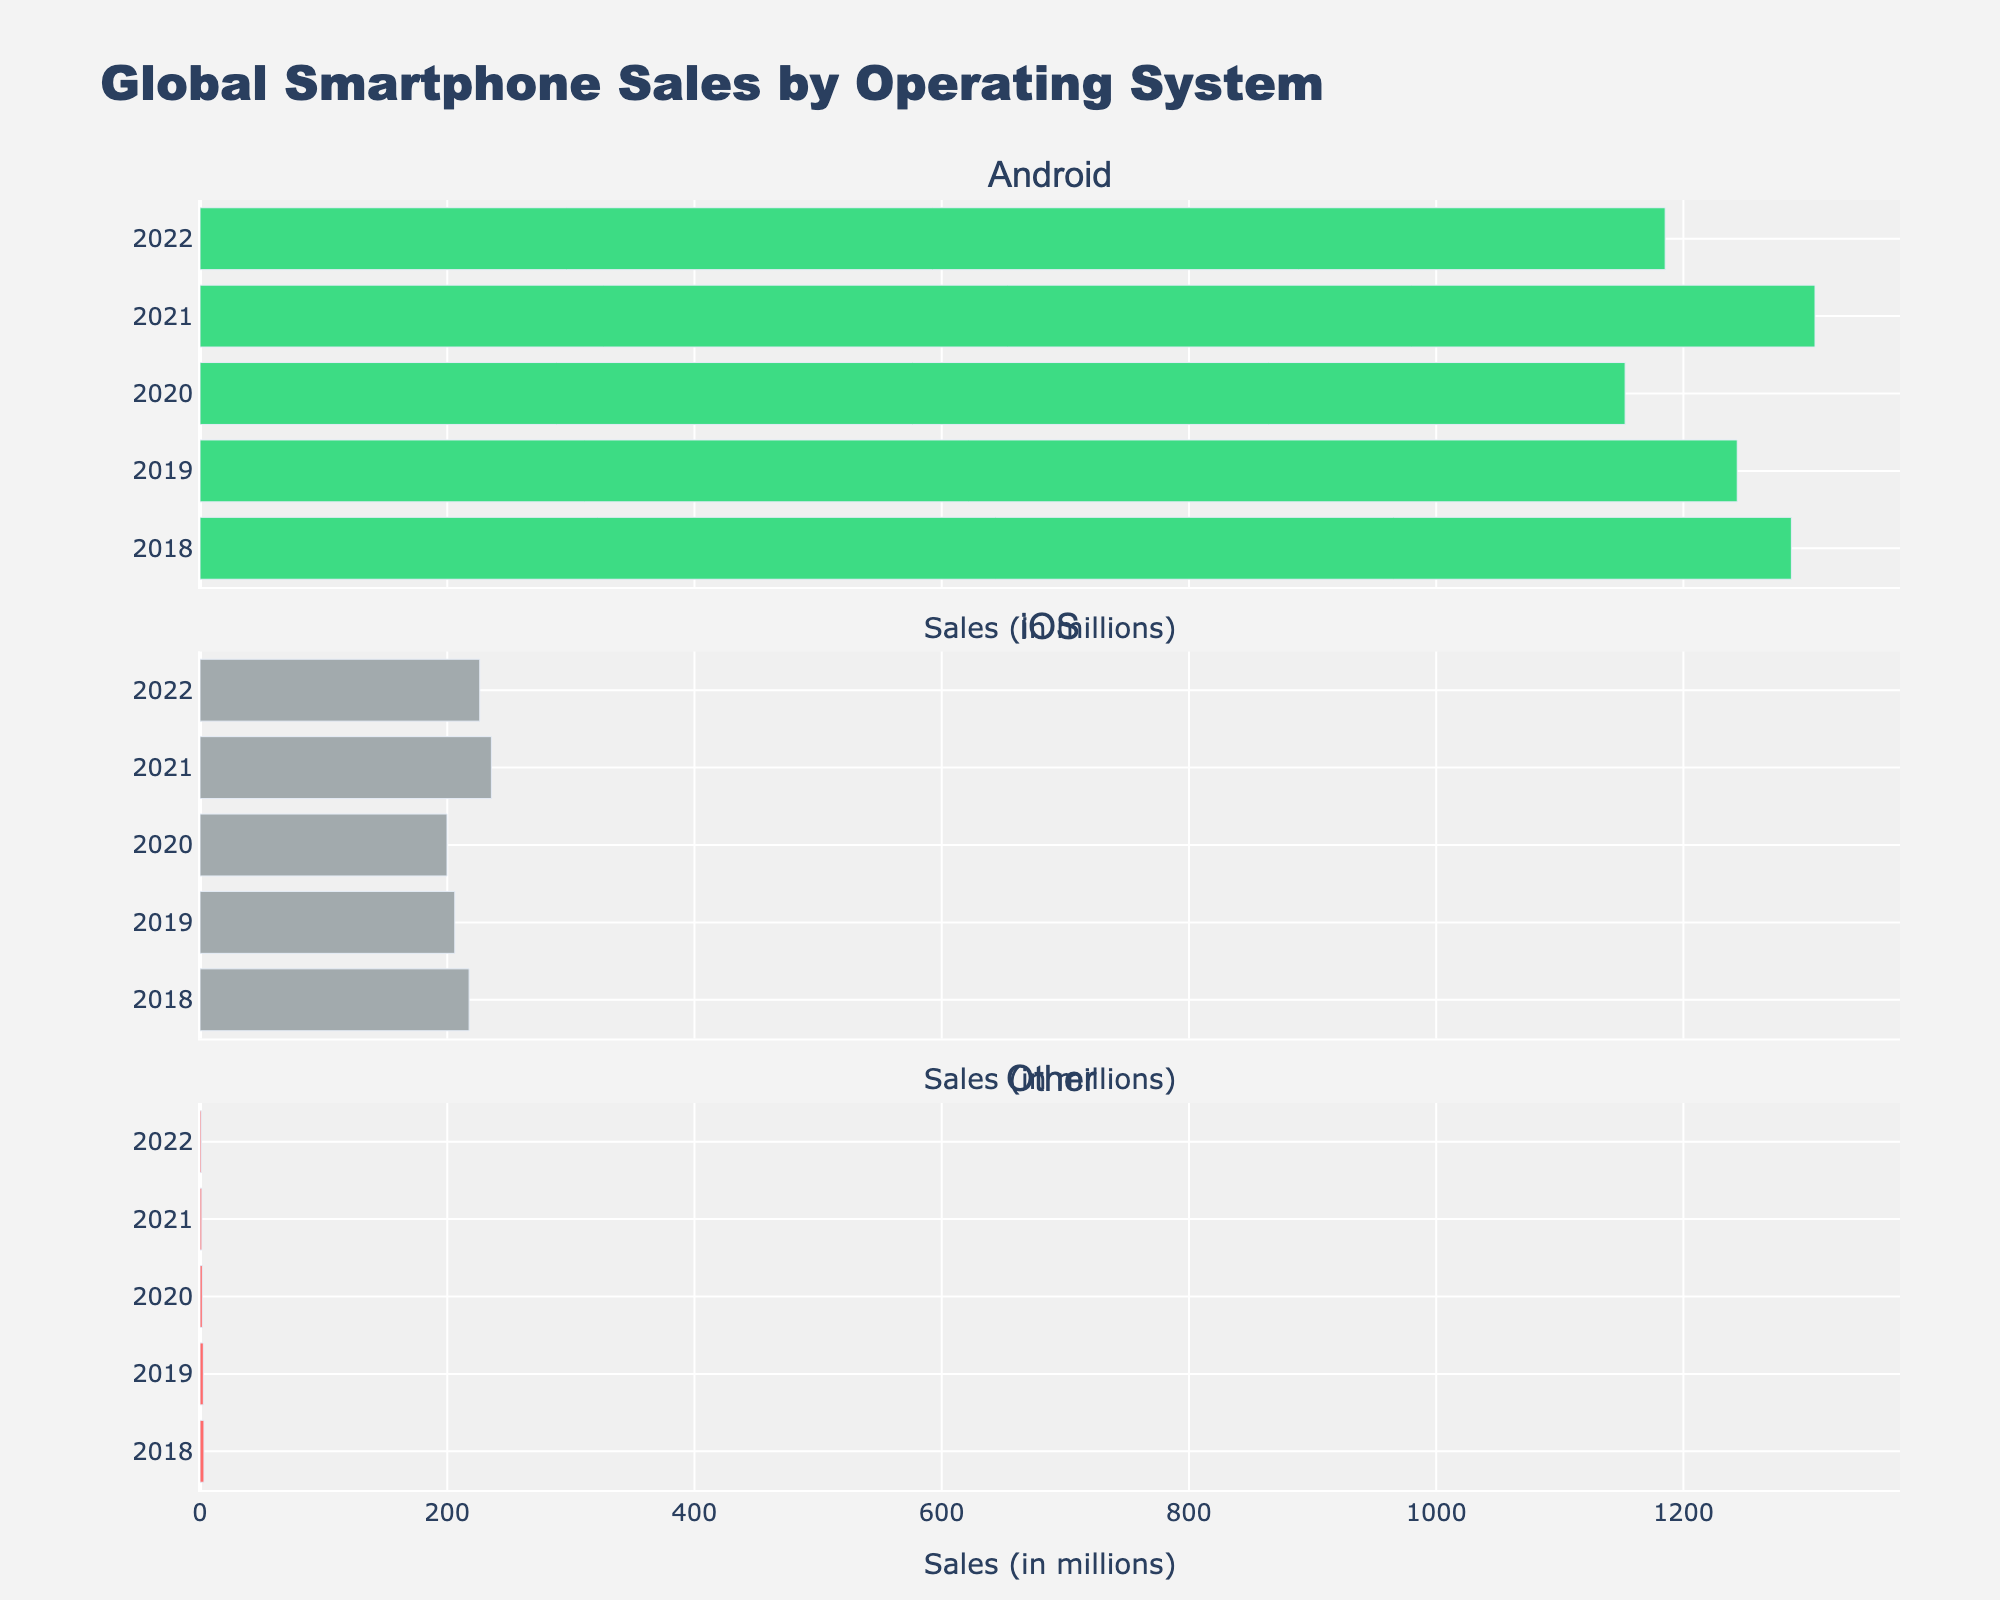What is the title of the figure? The title of a figure is typically located at the top. In this case, it reads "Comparison of Mood-Boosting Nutrients in Different Foods."
Answer: Comparison of Mood-Boosting Nutrients in Different Foods Which food item has the highest amount of Omega-3? To find the food with the highest Omega-3, look at the "Omega-3" subplot where all food items are listed along the x-axis and their Omega-3 content on the y-axis. The tallest bar represents Walnuts.
Answer: Walnuts What's the total amount of Tryptophan in Salmon and Turkey combined? First, find the Tryptophan levels for Salmon and Turkey in the "Tryptophan" subplot. Salmon has 350 mg and Turkey has 250 mg. Combined, they equal 350 + 250 = 600 mg.
Answer: 600 mg Which food has the lowest amount of Magnesium? To determine which food has the least Magnesium, locate the "Magnesium" subplot and compare the heights of the bars. Eggs have the shortest bar, indicating the lowest content.
Answer: Eggs How many subplots are used to show nutrient levels? The number of subplots can be seen by counting distinct areas of the graph, each showing data for a different nutrient. There are 5 nutrients so 5 subplots are used.
Answer: 5 Is there any food item that contains more than 200 mg of Tryptophan? In the "Tryptophan" subplot, observe the bars' heights. Salmon, Turkey, and Lentils all exceed 200 mg of Tryptophan.
Answer: Yes Which food has more Vitamin B6: Spinach or Lentils? Compare the bars for Spinach and Lentils in the "Vitamin B6" subplot. Lentils have a taller bar, implying higher Vitamin B6 content.
Answer: Lentils By how much does Magnesium content in Dark Chocolate exceed that in Bananas? Find the Magnesium levels in the "Magnesium" subplot for Dark Chocolate and Bananas. Dark Chocolate has 228 mg while Bananas have 33 mg. The difference is 228 - 33 = 195 mg.
Answer: 195 mg What are the units for measuring Omega-3 in the figure? Units for Omega-3 are indicated by the y-axis label in the "Omega-3" subplot. The label shows it is measured in grams.
Answer: grams 